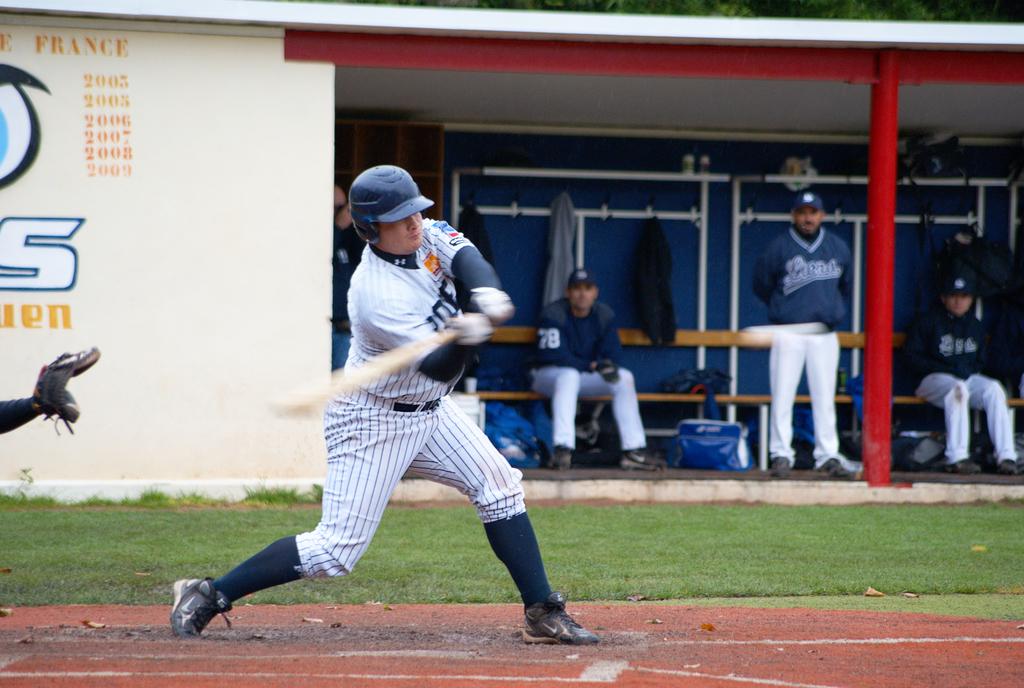What's the last year on the wall?
Make the answer very short. 2009. What is the first year on the wall?
Ensure brevity in your answer.  2003. 